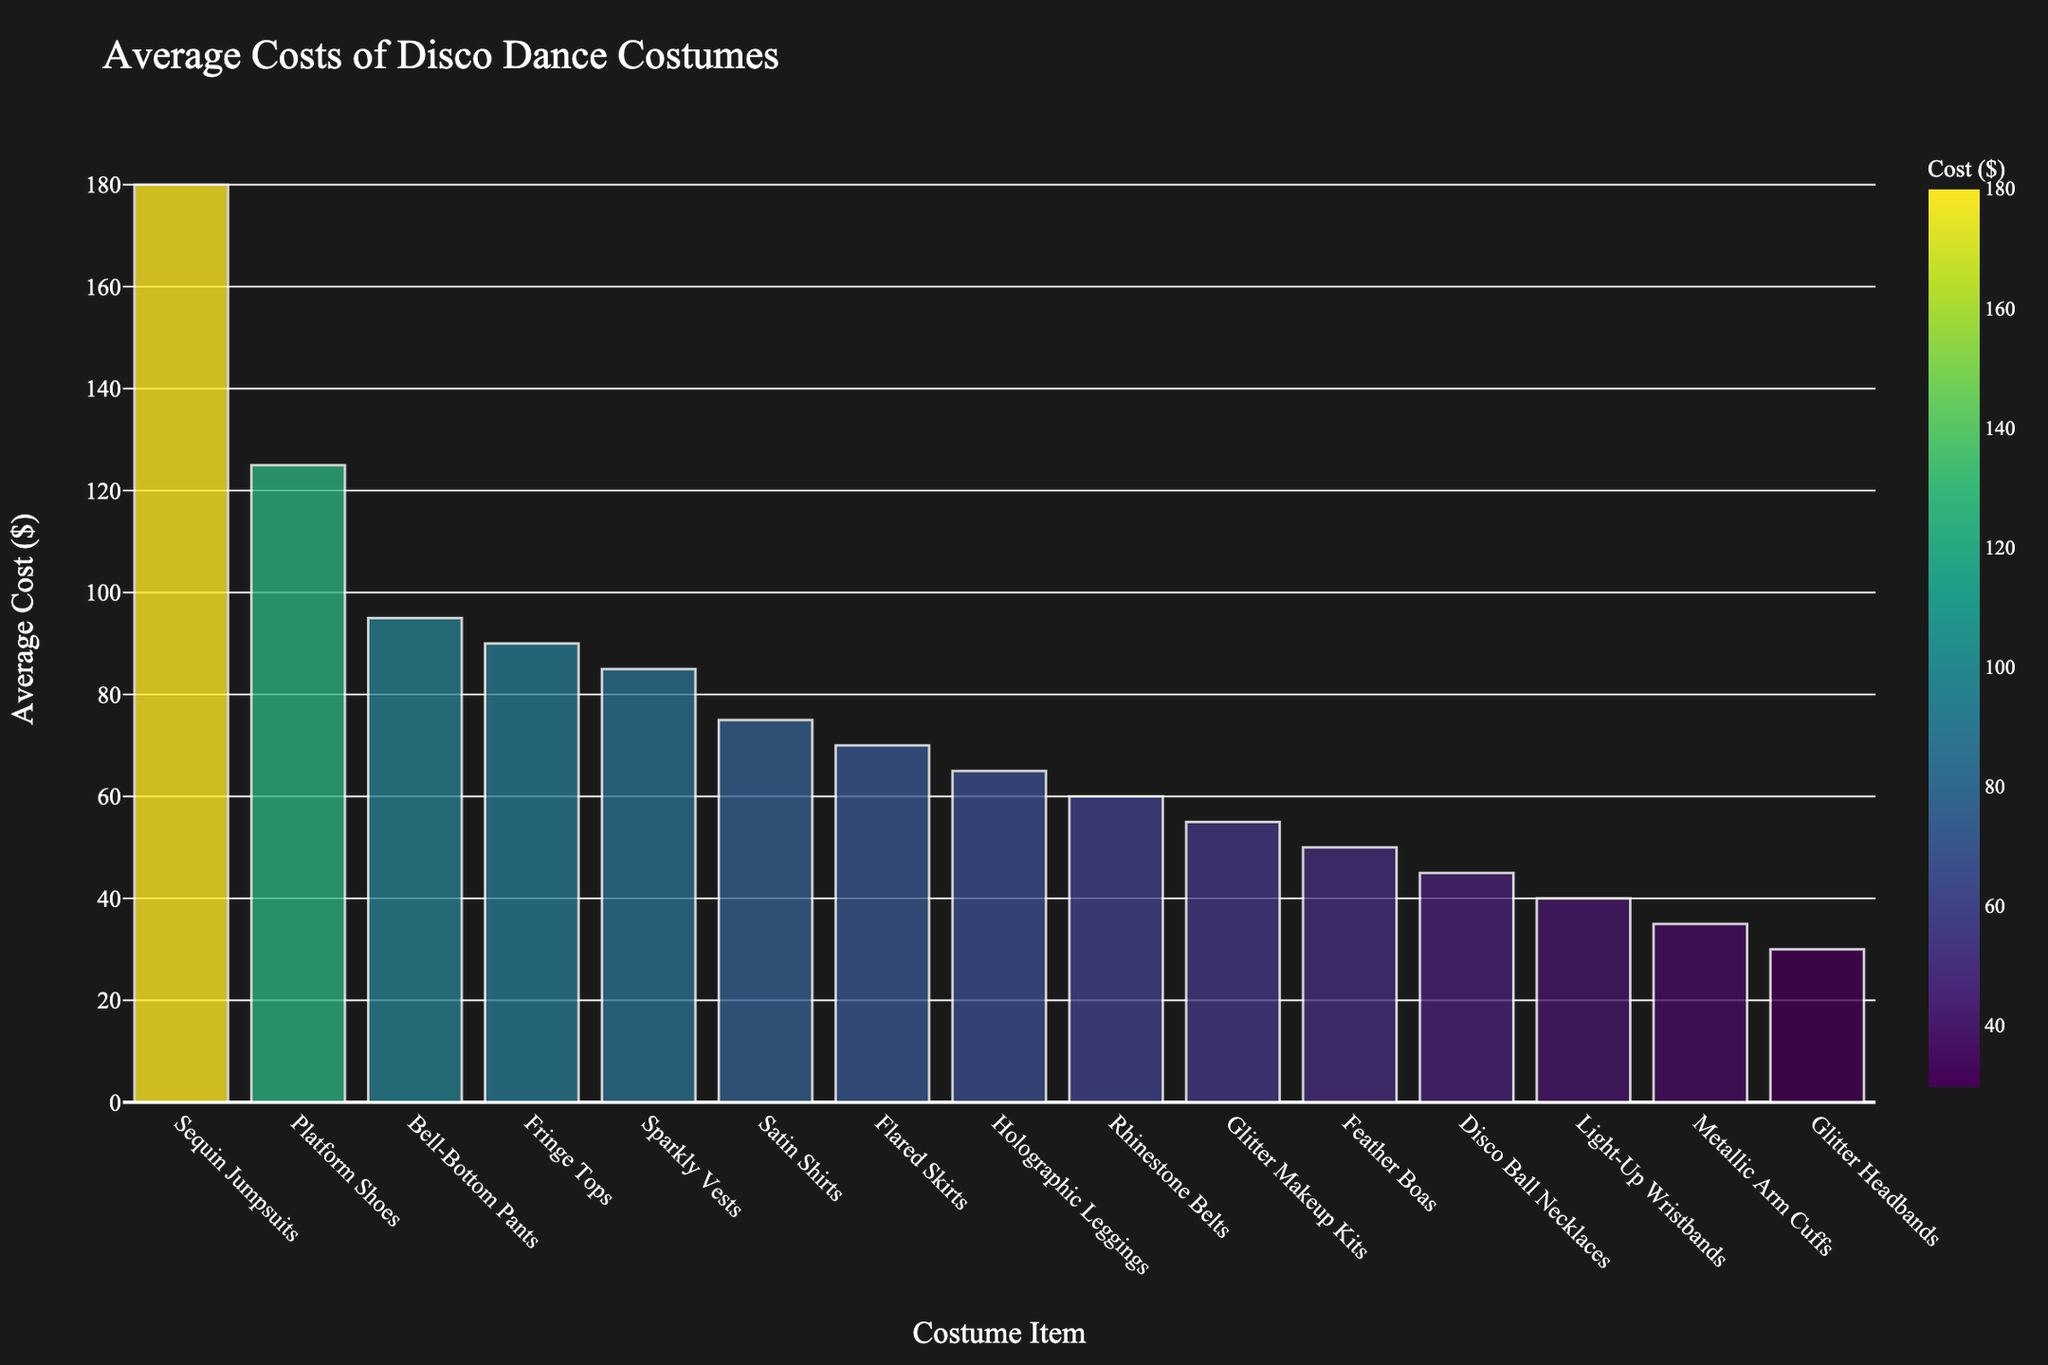Which category has the highest average cost? The bar chart shows the tallest bar under "Sequin Jumpsuits," which corresponds to the highest average cost.
Answer: Sequin Jumpsuits How much more expensive are Sequin Jumpsuits compared to Glitter Makeup Kits? The bar for Sequin Jumpsuits indicates an average cost of $180, and Glitter Makeup Kits show $55. Subtracting $55 from $180 gives the difference.
Answer: $125 Which categories have an average cost greater than $100? By looking at the bar heights, the categories with bars higher than $100 are Sequin Jumpsuits and Platform Shoes.
Answer: Sequin Jumpsuits, Platform Shoes What is the total cost if one buys a Platform Shoe, a Rhinestone Belt, and a Holographic Legging? Adding the average costs: Platform Shoes ($125) + Rhinestone Belt ($60) + Holographic Legging ($65) = $250.
Answer: $250 Is the average cost of Fringe Tops greater than that of Bell-Bottom Pants? Comparing the bars for Fringe Tops ($90) and Bell-Bottom Pants ($95), the bar for Bell-Bottom Pants is slightly higher.
Answer: No Which item costs the least on average? The shortest bar corresponds to the lowest cost, which is "Glitter Headbands" at $30.
Answer: Glitter Headbands What is the combined average cost of Feather Boas, Light-Up Wristbands, and Flared Skirts? Adding the average costs: Feather Boas ($50) + Light-Up Wristbands ($40) + Flared Skirts ($70) = $160.
Answer: $160 Are the categories with costs between $90 and $100 more frequent than those between $50 and $60? There are two bars in the $90-$100 range (Bell-Bottom Pants, Fringe Tops) and three bars in the $50-$60 range (Rhinestone Belts, Feather Boas, Glitter Makeup Kits).
Answer: No What is the average cost of all the accessories listed (Rhinestone Belts, Glitter Headbands, Disco Ball Necklaces, Metallic Arm Cuffs, Feather Boas, Light-Up Wristbands, Glitter Makeup Kits)? Adding the costs and dividing by 7: ($60 + $30 + $45 + $35 + $50 + $40 + $55) / 7 = $44.29 (approx).
Answer: $44.29 